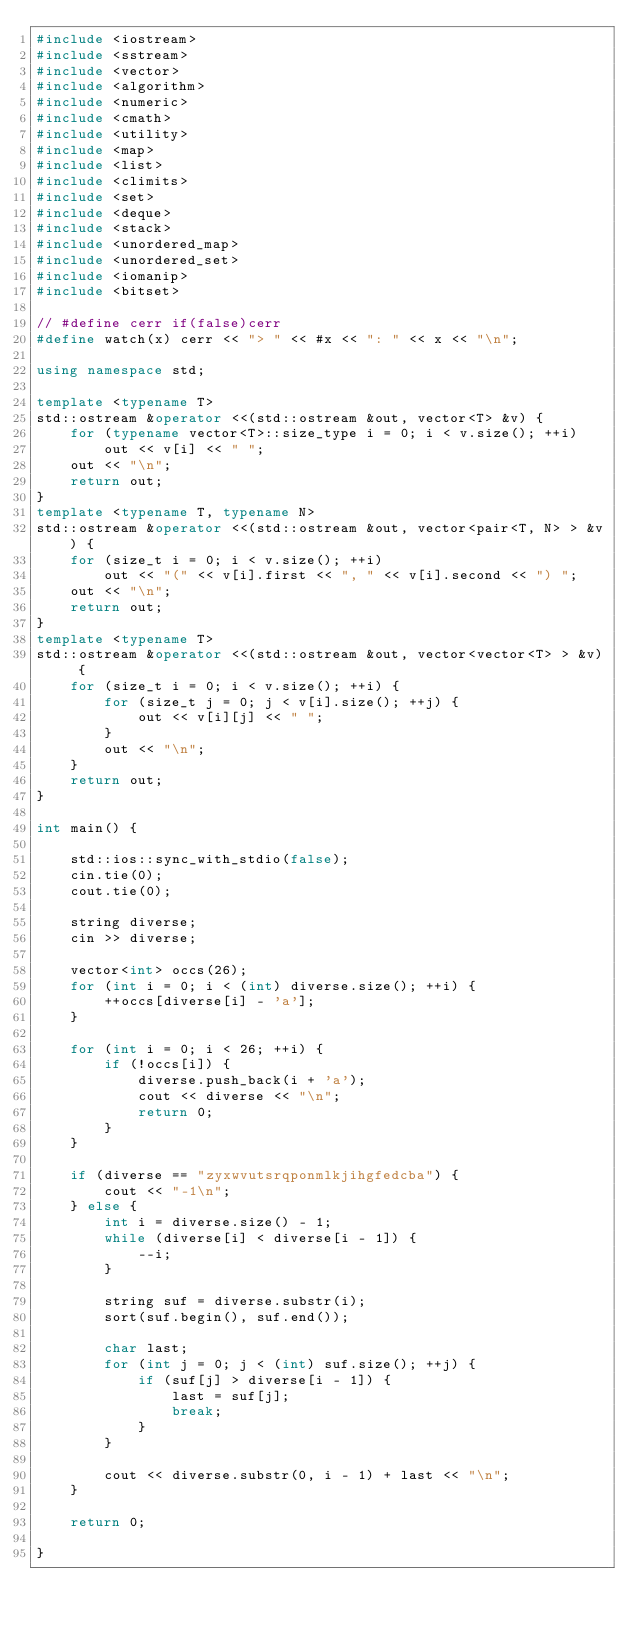<code> <loc_0><loc_0><loc_500><loc_500><_C++_>#include <iostream>
#include <sstream>
#include <vector>
#include <algorithm>
#include <numeric>
#include <cmath>
#include <utility>
#include <map>
#include <list>
#include <climits>
#include <set>
#include <deque>
#include <stack>
#include <unordered_map>
#include <unordered_set>
#include <iomanip>
#include <bitset>

// #define cerr if(false)cerr
#define watch(x) cerr << "> " << #x << ": " << x << "\n";

using namespace std;

template <typename T>
std::ostream &operator <<(std::ostream &out, vector<T> &v) {
	for (typename vector<T>::size_type i = 0; i < v.size(); ++i)
		out << v[i] << " ";
	out << "\n";
    return out;
}
template <typename T, typename N>
std::ostream &operator <<(std::ostream &out, vector<pair<T, N> > &v) {
	for (size_t i = 0; i < v.size(); ++i)
		out << "(" << v[i].first << ", " << v[i].second << ") ";
	out << "\n";
    return out;
}
template <typename T>
std::ostream &operator <<(std::ostream &out, vector<vector<T> > &v) {
	for (size_t i = 0; i < v.size(); ++i) {
		for (size_t j = 0; j < v[i].size(); ++j) {
			out << v[i][j] << " ";
		}
		out << "\n";
	}
   	return out;
}

int main() {

	std::ios::sync_with_stdio(false);
	cin.tie(0);
	cout.tie(0);

	string diverse;
	cin >> diverse;

	vector<int> occs(26);
	for (int i = 0; i < (int) diverse.size(); ++i) {
		++occs[diverse[i] - 'a'];
	}

	for (int i = 0; i < 26; ++i) {
		if (!occs[i]) {
			diverse.push_back(i + 'a');
			cout << diverse << "\n";
			return 0;
		}
	}

	if (diverse == "zyxwvutsrqponmlkjihgfedcba") {
		cout << "-1\n";
	} else {
		int i = diverse.size() - 1;
		while (diverse[i] < diverse[i - 1]) {
			--i;
		}

		string suf = diverse.substr(i);
		sort(suf.begin(), suf.end());

		char last;
		for (int j = 0; j < (int) suf.size(); ++j) {
			if (suf[j] > diverse[i - 1]) {
				last = suf[j];
				break;
			}
		}

		cout << diverse.substr(0, i - 1) + last << "\n";
	}

	return 0;

}</code> 